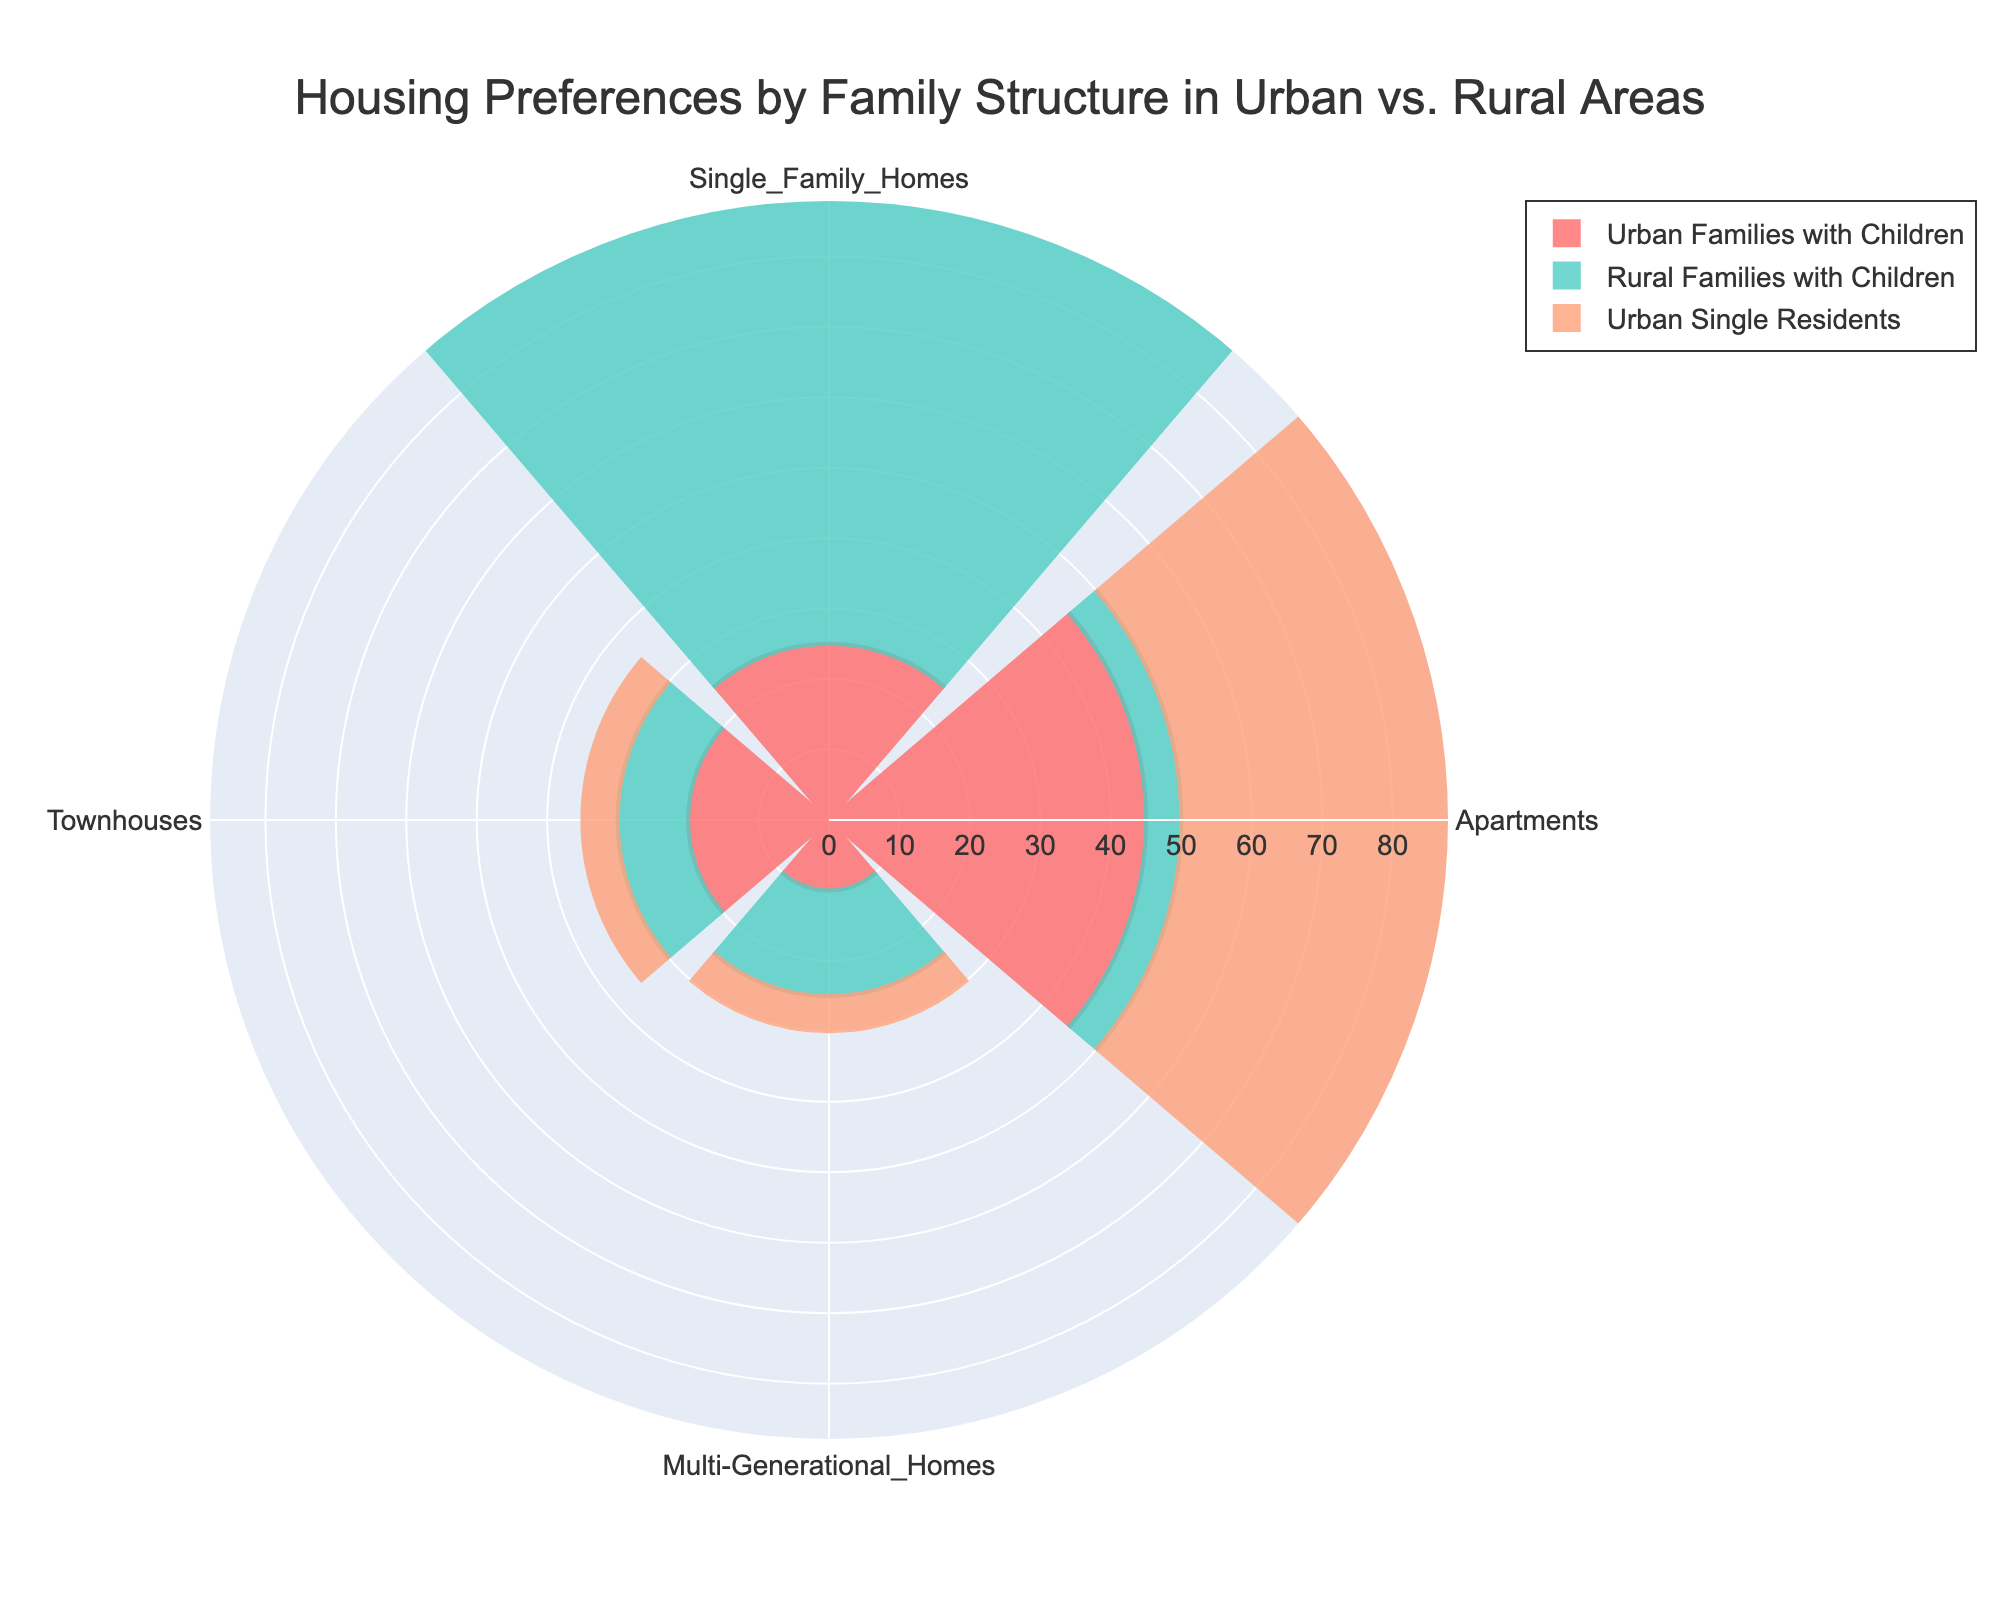What's the title of the figure? The title is typically displayed at the top of the figure, summarizing the main subject.
Answer: Housing Preferences by Family Structure in Urban vs. Rural Areas How many categories of housing preferences are displayed in the chart? Count the distinct housing categories represented by each segment of the rose chart.
Answer: 4 Which housing preference do urban single residents prefer the most? Compare the lengths of the segments for urban single residents across all categories. The longest segment indicates the most preferred category.
Answer: Apartments What is the combined preference for townhouses by rural families with children and urban single residents? Add the values for townhouses for both rural families with children and urban single residents (10 + 5).
Answer: 15 Which group shows the least preference for apartments? Identify the group with the smallest segment for apartments.
Answer: Rural Families with Children Do urban families with children prefer single-family homes more than rural families with children? Compare the segments for single-family homes for both urban and rural families with children. Urban families with children prefer single-family homes less (25 vs. 70).
Answer: No What is the difference in preference for multi-generational homes between rural single residents and urban families with children? Subtract the value for urban families with children from the value for rural single residents (50 - 10).
Answer: 40 Which housing type shows the least preference among urban couples without children? Identify the shortest segment for urban couples without children across all categories.
Answer: Townhouses Which group appears to have the most varied distribution of housing preferences? Examine the range of segment lengths for each group. The group with the largest variations in segment lengths shows the most varied preferences.
Answer: Rural Single Residents 